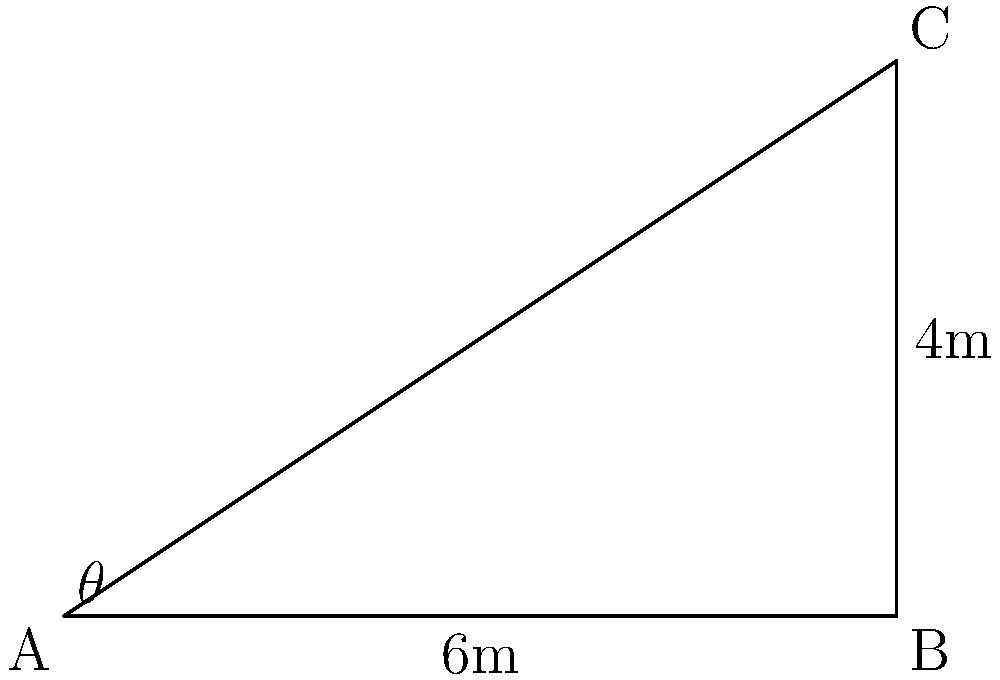In your warehouse, you need to install a conveyor belt from point A to point C to transport inventory efficiently. The horizontal distance from A to B is 6 meters, and the vertical distance from B to C is 4 meters. What angle $\theta$ should the conveyor belt be set at to maximize efficiency? To find the optimal angle for the conveyor belt, we need to use trigonometry:

1. We have a right triangle ABC, where:
   - AB is the horizontal distance (adjacent to angle $\theta$) = 6 meters
   - BC is the vertical distance (opposite to angle $\theta$) = 4 meters
   - AC is the hypotenuse (length of the conveyor belt)

2. To find angle $\theta$, we can use the tangent function:

   $\tan \theta = \frac{\text{opposite}}{\text{adjacent}} = \frac{BC}{AB} = \frac{4}{6}$

3. To get the angle, we need to use the inverse tangent (arctan or $\tan^{-1}$):

   $\theta = \tan^{-1}(\frac{4}{6})$

4. Simplify the fraction:
   
   $\theta = \tan^{-1}(\frac{2}{3})$

5. Calculate:
   
   $\theta \approx 33.69°$

Therefore, the optimal angle for the conveyor belt to maximize efficiency is approximately 33.69 degrees.
Answer: $33.69°$ 